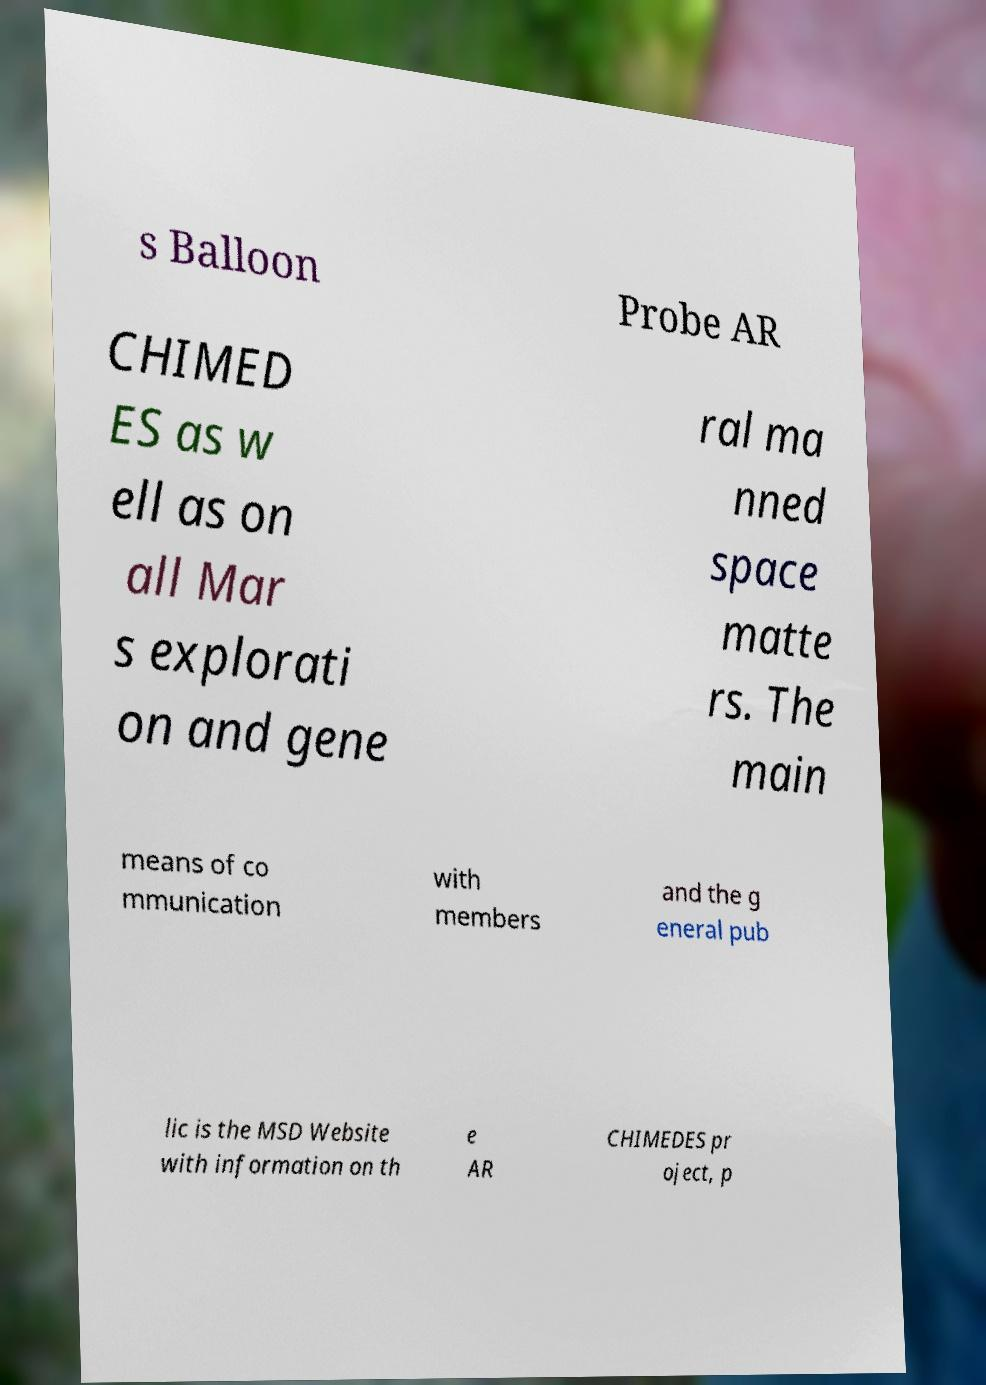Could you assist in decoding the text presented in this image and type it out clearly? s Balloon Probe AR CHIMED ES as w ell as on all Mar s explorati on and gene ral ma nned space matte rs. The main means of co mmunication with members and the g eneral pub lic is the MSD Website with information on th e AR CHIMEDES pr oject, p 